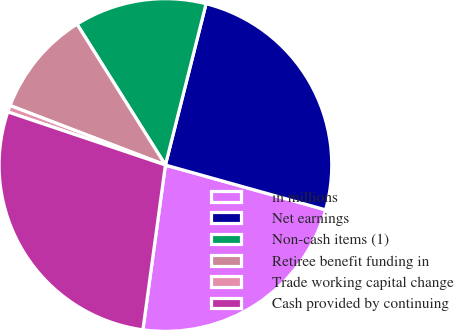Convert chart to OTSL. <chart><loc_0><loc_0><loc_500><loc_500><pie_chart><fcel>in millions<fcel>Net earnings<fcel>Non-cash items (1)<fcel>Retiree benefit funding in<fcel>Trade working capital change<fcel>Cash provided by continuing<nl><fcel>22.82%<fcel>25.41%<fcel>12.85%<fcel>10.26%<fcel>0.65%<fcel>28.01%<nl></chart> 